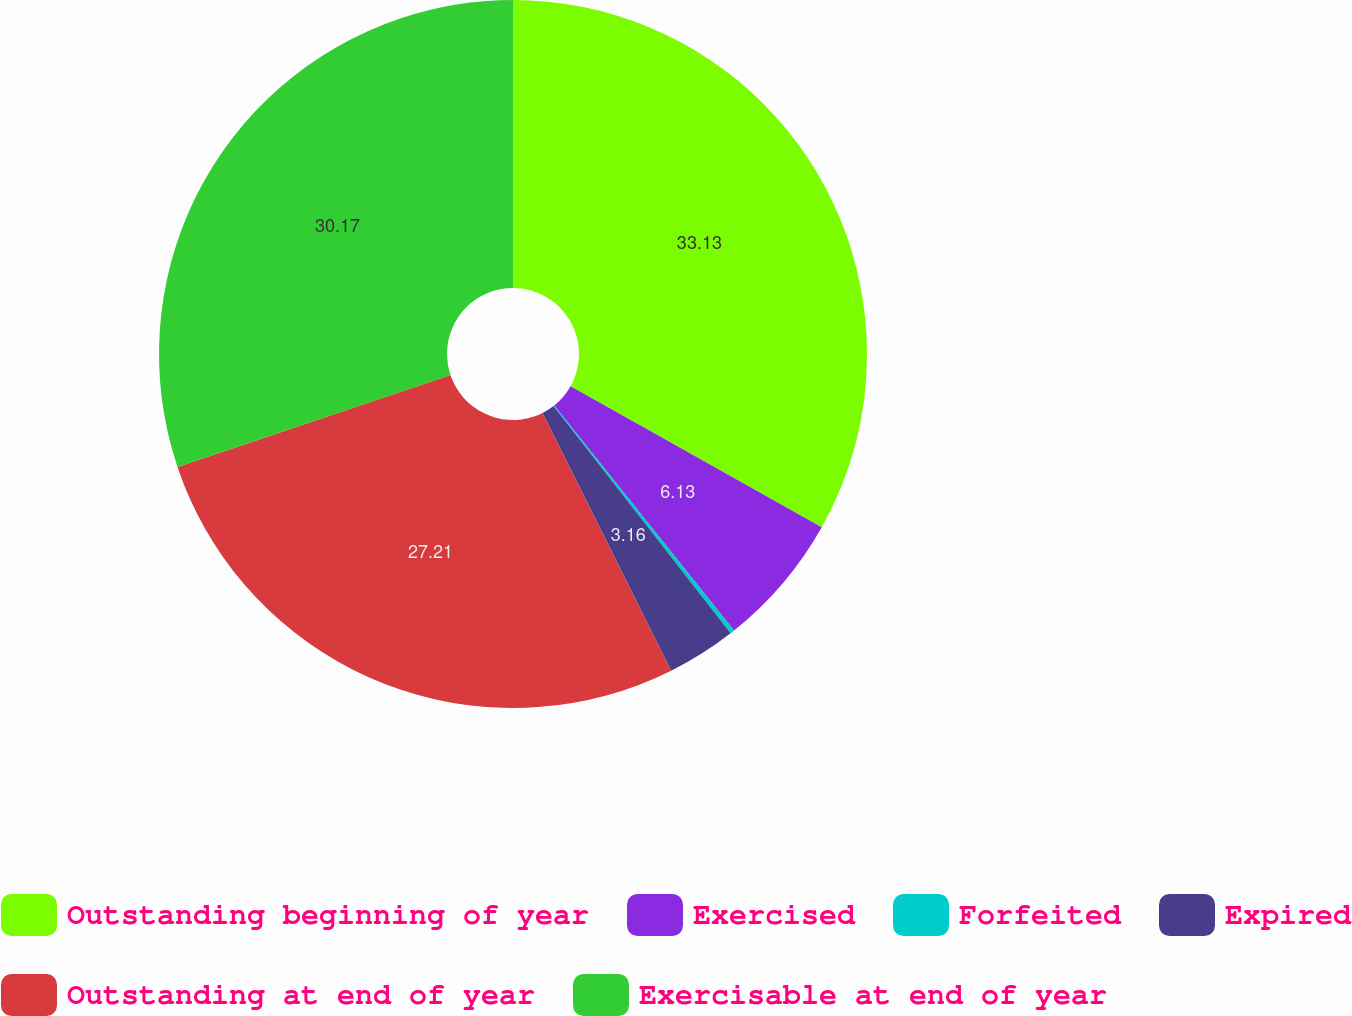Convert chart to OTSL. <chart><loc_0><loc_0><loc_500><loc_500><pie_chart><fcel>Outstanding beginning of year<fcel>Exercised<fcel>Forfeited<fcel>Expired<fcel>Outstanding at end of year<fcel>Exercisable at end of year<nl><fcel>33.14%<fcel>6.13%<fcel>0.2%<fcel>3.16%<fcel>27.21%<fcel>30.17%<nl></chart> 